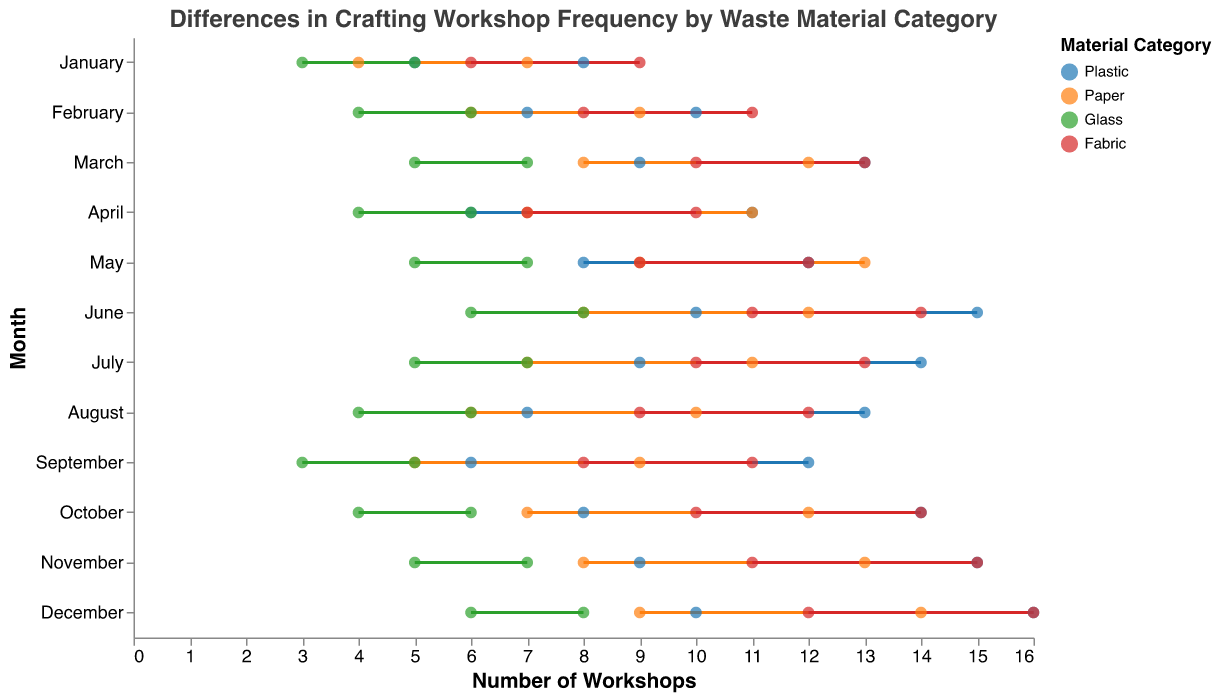What is the title of the plot? The title is displayed at the top center of the plot. It summarizes the main subject of the plot, describing what the data represents.
Answer: Differences in Crafting Workshop Frequency by Waste Material Category Which material category has the most significant increase from the start to the end of the year in October? By comparing the difference between the start and end workshop counts for each material category in October, the material with the largest increase is identified. Fabric shows the largest increase from 10 to 14.
Answer: Fabric How many more workshops did Plastic have at the end of January compared to the start? Subtract the start-of-year workshop count from the end-of-year workshop count for Plastic in January. It is 8 - 5.
Answer: 3 On average, how many workshops did Glass have at the start of the year? To find the average, sum the start-of-year workshop counts for all months for Glass and divide by 12. (3+4+5+4+5+6+5+4+3+4+5+6)/12 = 4.58.
Answer: 4.58 Which material category has the smallest difference between the start and end of the year in July? Subtract the start-of-year workshop count from the end-of-year workshop count in July for each material category. Identify the smallest difference. Glass has a difference of 2 (7-5).
Answer: Glass Compare the changes in workshop counts for Paper and Fabric from November to December. Which category had a larger increase? Calculate the workshop count difference for Paper (14-13=1) and Fabric (16-15=1). Both had an increase of 1 workshop.
Answer: Equal What is the total number of workshops for all material categories at the start of April? Sum the start-of-year workshop counts for each material category in April. It is (6+7+4+7).
Answer: 24 Did any material category have the same number of workshops at the end of the year in two consecutive months? If so, which month and material? Examine the workshop counts for all months and material categories. Fabric had 13 workshops at the end of March and April.
Answer: Fabric, March and April What is the range of workshop counts for Plastic at the start of the year across all months? Identify the minimum and maximum workshop counts for Plastic at the start of the year. Min is 5 (January), max is 10 (June, December), so the range is 10-5.
Answer: 5 In which month did Paper see the highest increase in workshop counts from the start to the end of the year? Calculate the difference between the start and end workshop counts for Paper in each month and identify the highest increase. October saw the highest increase from 7 to 12.
Answer: October 